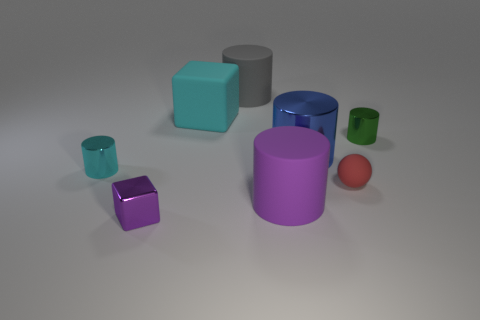There is a object that is the same color as the matte block; what is its size?
Provide a short and direct response. Small. Does the tiny matte thing have the same shape as the big shiny object?
Provide a short and direct response. No. There is a green metallic thing that is the same shape as the big gray matte object; what is its size?
Offer a very short reply. Small. There is a metallic object in front of the cylinder on the left side of the large cyan rubber cube; what shape is it?
Offer a very short reply. Cube. What size is the metallic block?
Make the answer very short. Small. There is a red matte thing; what shape is it?
Your answer should be very brief. Sphere. Do the tiny green metal object and the tiny shiny thing left of the purple shiny block have the same shape?
Offer a very short reply. Yes. Does the small object to the left of the purple cube have the same shape as the tiny red thing?
Give a very brief answer. No. How many cylinders are both left of the gray matte thing and behind the tiny green cylinder?
Ensure brevity in your answer.  0. What number of other objects are the same size as the blue thing?
Make the answer very short. 3. 